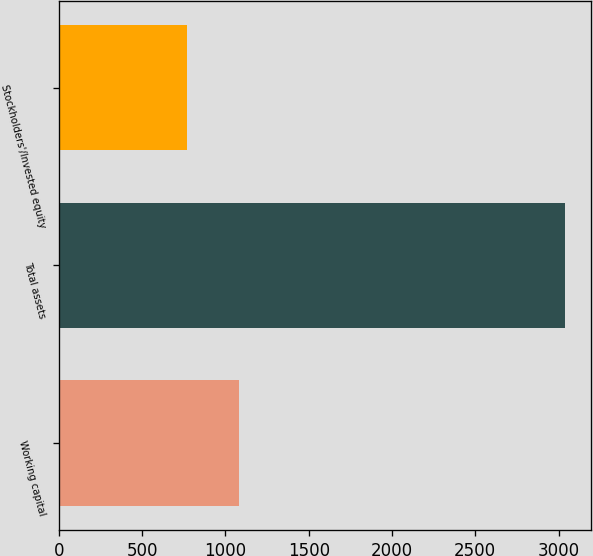<chart> <loc_0><loc_0><loc_500><loc_500><bar_chart><fcel>Working capital<fcel>Total assets<fcel>Stockholders'/Invested equity<nl><fcel>1081<fcel>3041<fcel>769<nl></chart> 